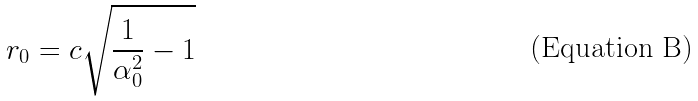<formula> <loc_0><loc_0><loc_500><loc_500>r _ { 0 } = c \sqrt { \frac { 1 } { \alpha _ { 0 } ^ { 2 } } - 1 }</formula> 